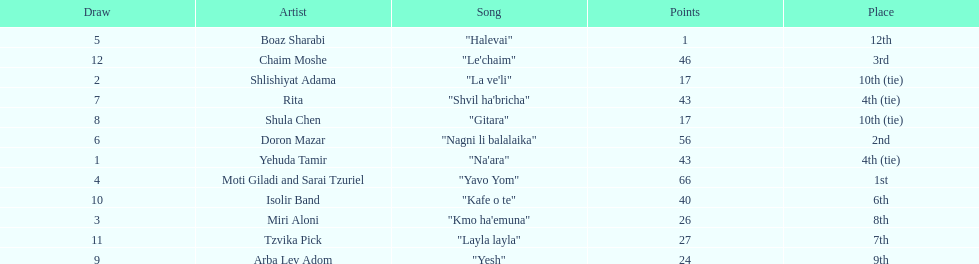How many points does the artist rita have? 43. Parse the full table. {'header': ['Draw', 'Artist', 'Song', 'Points', 'Place'], 'rows': [['5', 'Boaz Sharabi', '"Halevai"', '1', '12th'], ['12', 'Chaim Moshe', '"Le\'chaim"', '46', '3rd'], ['2', 'Shlishiyat Adama', '"La ve\'li"', '17', '10th (tie)'], ['7', 'Rita', '"Shvil ha\'bricha"', '43', '4th (tie)'], ['8', 'Shula Chen', '"Gitara"', '17', '10th (tie)'], ['6', 'Doron Mazar', '"Nagni li balalaika"', '56', '2nd'], ['1', 'Yehuda Tamir', '"Na\'ara"', '43', '4th (tie)'], ['4', 'Moti Giladi and Sarai Tzuriel', '"Yavo Yom"', '66', '1st'], ['10', 'Isolir Band', '"Kafe o te"', '40', '6th'], ['3', 'Miri Aloni', '"Kmo ha\'emuna"', '26', '8th'], ['11', 'Tzvika Pick', '"Layla layla"', '27', '7th'], ['9', 'Arba Lev Adom', '"Yesh"', '24', '9th']]} 